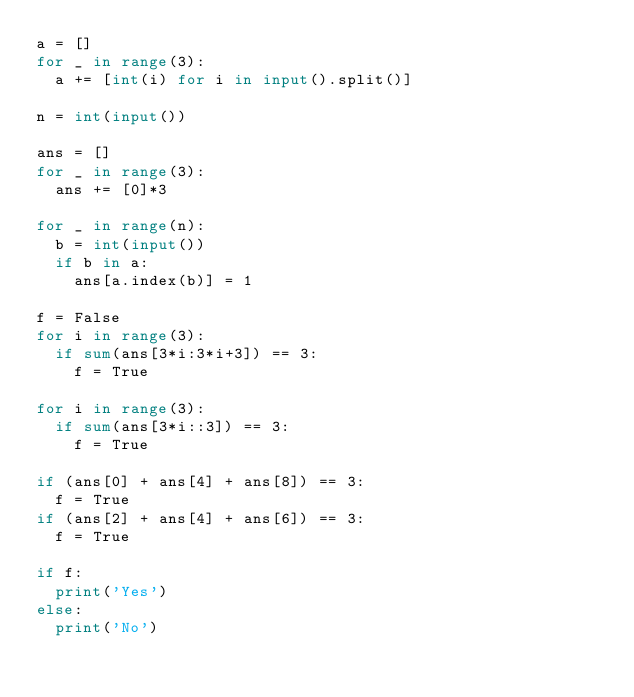<code> <loc_0><loc_0><loc_500><loc_500><_Python_>a = []
for _ in range(3):
  a += [int(i) for i in input().split()]

n = int(input())

ans = []
for _ in range(3):
  ans += [0]*3
  
for _ in range(n):
  b = int(input())
  if b in a:
    ans[a.index(b)] = 1
    
f = False
for i in range(3):
  if sum(ans[3*i:3*i+3]) == 3:
    f = True

for i in range(3):
  if sum(ans[3*i::3]) == 3:
    f = True
    
if (ans[0] + ans[4] + ans[8]) == 3:
  f = True
if (ans[2] + ans[4] + ans[6]) == 3:
  f = True
  
if f:
  print('Yes')
else:
  print('No')

</code> 